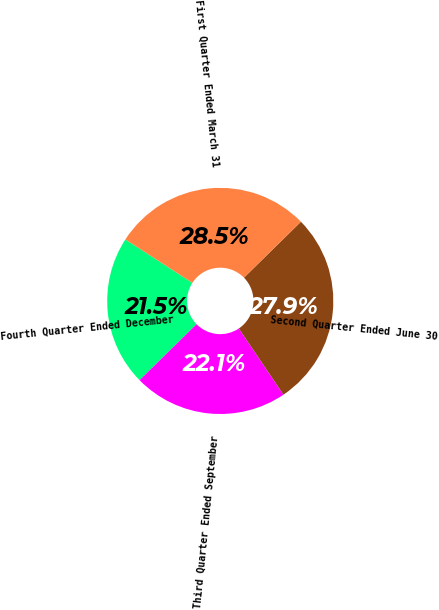Convert chart to OTSL. <chart><loc_0><loc_0><loc_500><loc_500><pie_chart><fcel>Fourth Quarter Ended December<fcel>Third Quarter Ended September<fcel>Second Quarter Ended June 30<fcel>First Quarter Ended March 31<nl><fcel>21.51%<fcel>22.09%<fcel>27.91%<fcel>28.49%<nl></chart> 